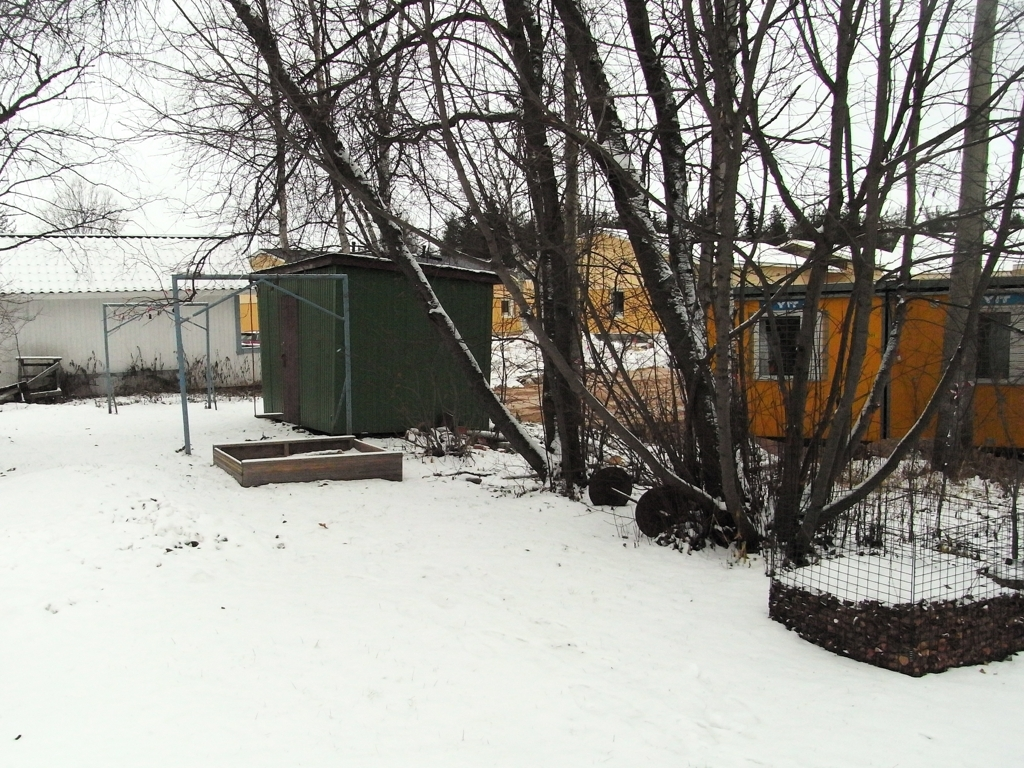What can you tell me about the structures in the image? There are several structures visible: a green shed on the left, an enclosed area with a mesh fence, possibly a garden or animal enclosure, and a building with large windows in the background, which could be a residential or commercial building. These structures suggest the image may be of a backyard or a community area. 